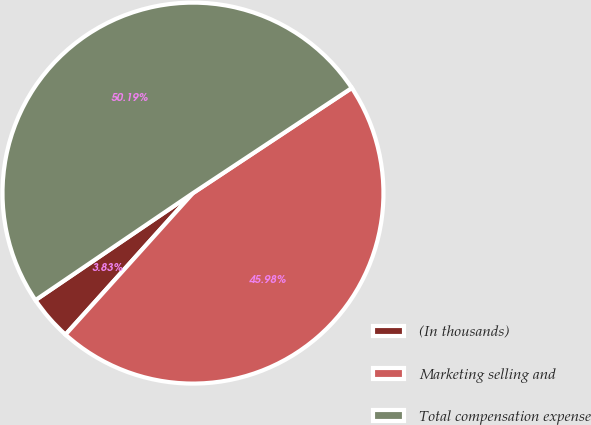Convert chart. <chart><loc_0><loc_0><loc_500><loc_500><pie_chart><fcel>(In thousands)<fcel>Marketing selling and<fcel>Total compensation expense<nl><fcel>3.83%<fcel>45.98%<fcel>50.19%<nl></chart> 